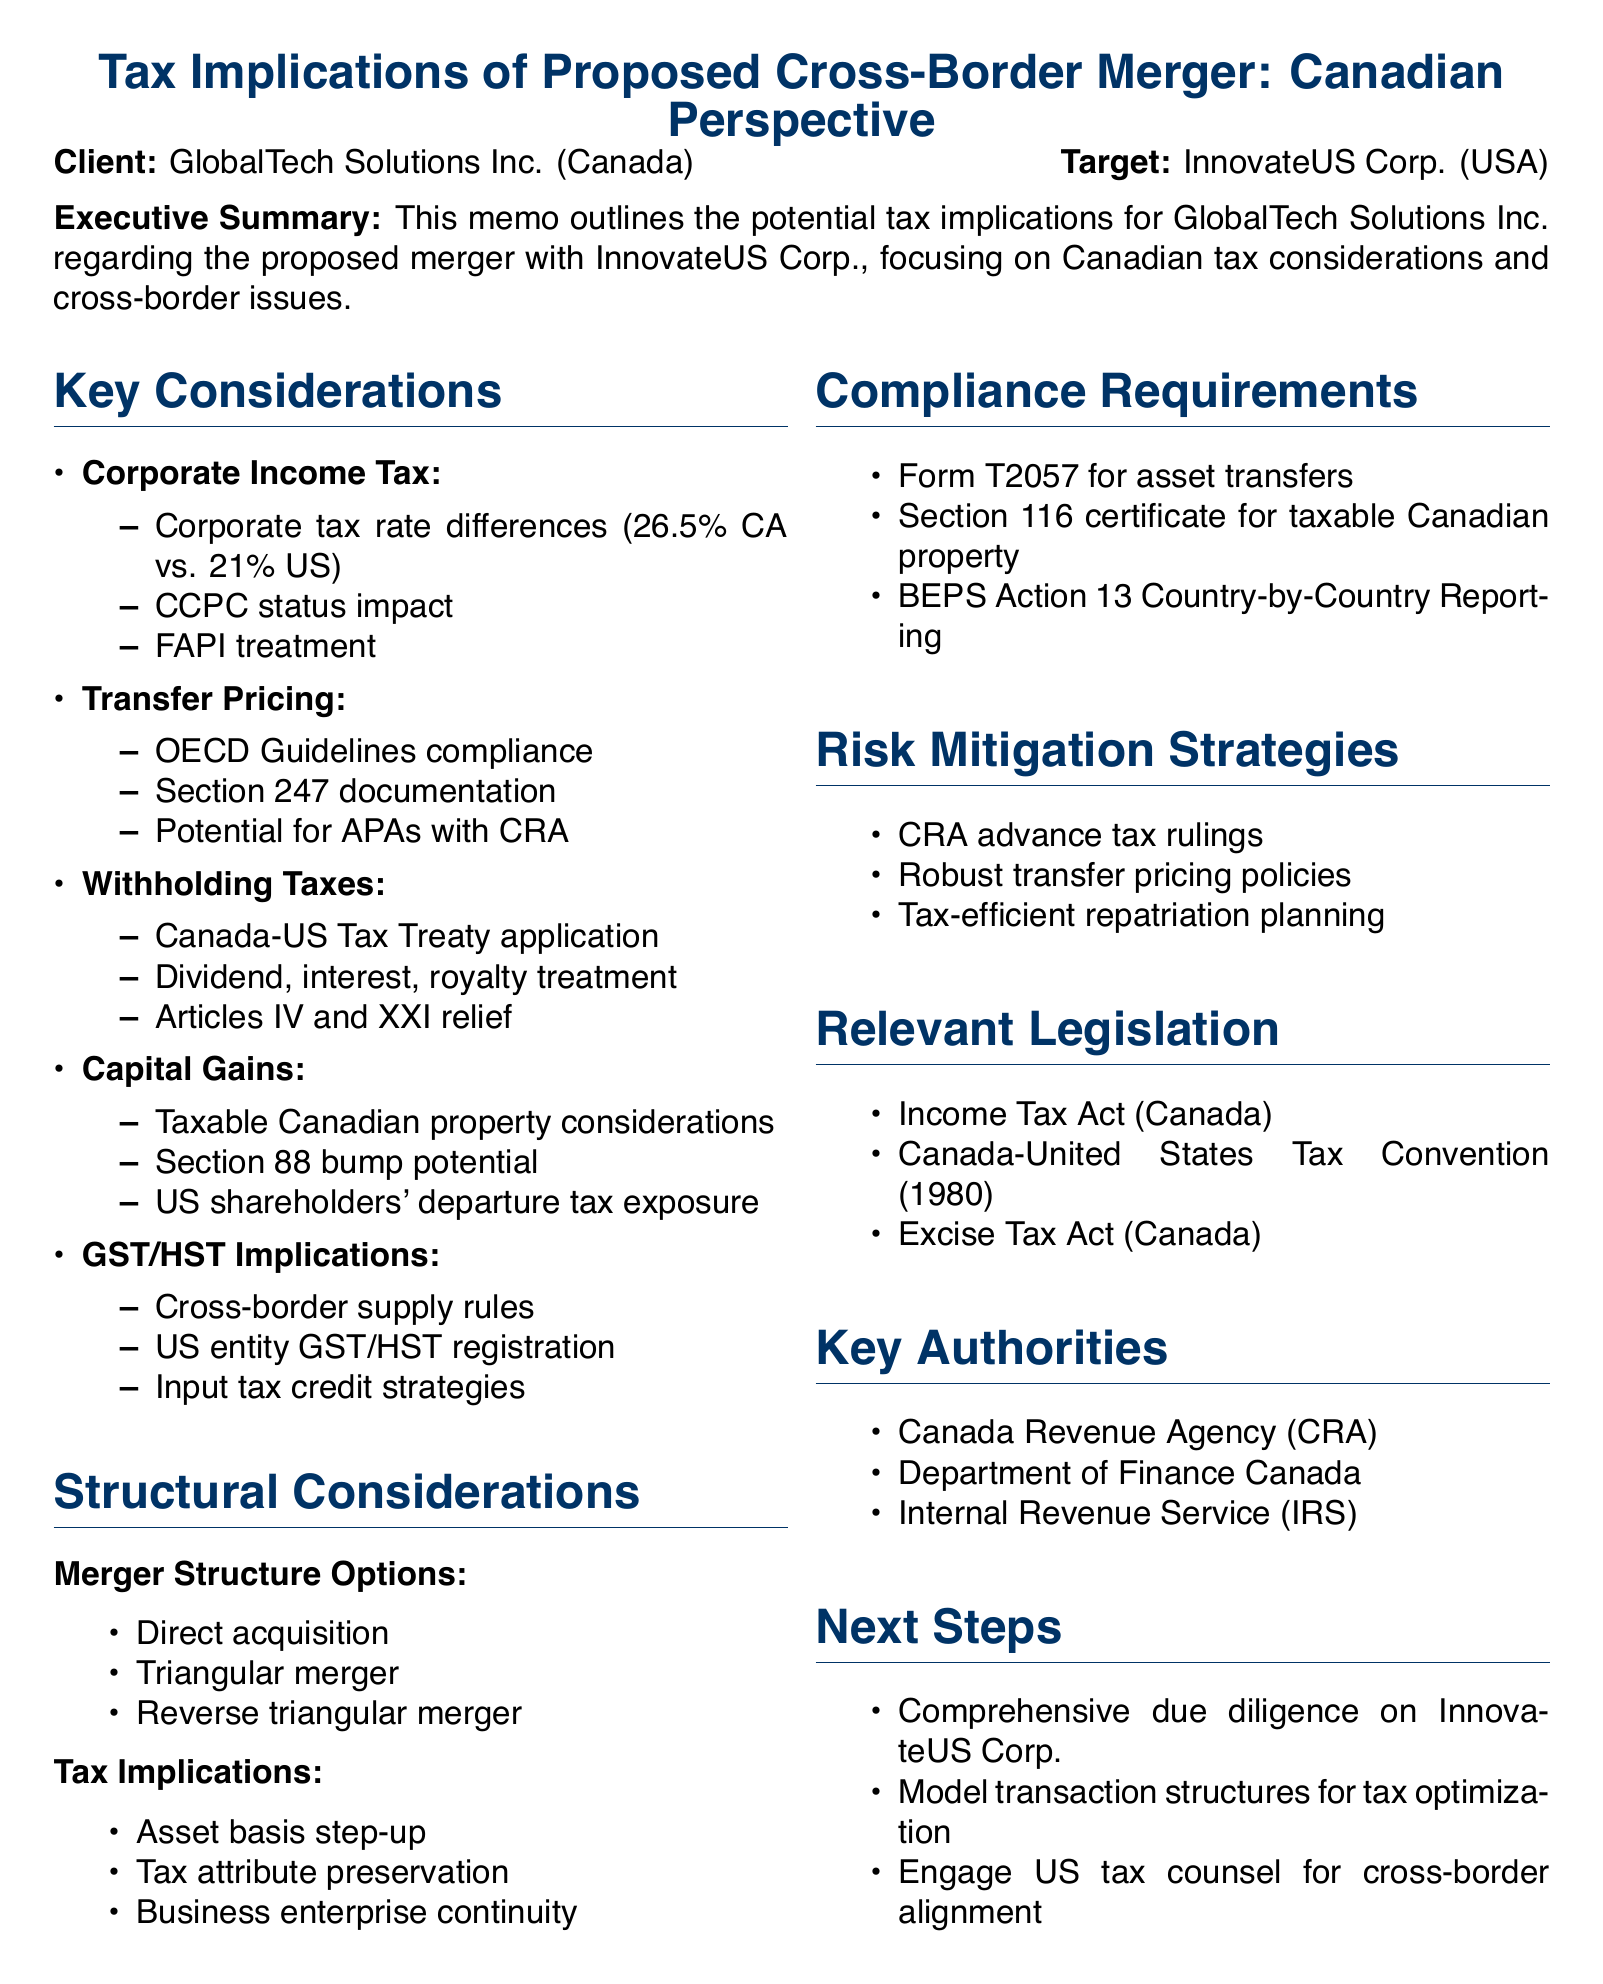what is the client name? The client name is explicitly mentioned in the document as GlobalTech Solutions Inc.
Answer: GlobalTech Solutions Inc what is the target company? The document identifies the target company involved in the merger as InnovateUS Corp.
Answer: InnovateUS Corp what is the corporate tax rate in Canada? The document states that the corporate tax rate in Canada is 26.5%.
Answer: 26.5% what is the potential application mentioned in Capital Gains? The document references the potential application of Section 88 bump on acquisition of Canadian target under Capital Gains considerations.
Answer: Section 88 bump which form is required for asset transfers? The document lists Form T2057 as necessary for asset transfers under compliance requirements.
Answer: Form T2057 what is one of the risk mitigation strategies suggested? The document advises obtaining advance tax rulings from CRA as a risk mitigation strategy.
Answer: Advance tax rulings from CRA what are the three merger structure options listed? The document outlines three options: direct acquisition, triangular merger, and reverse triangular merger.
Answer: Direct acquisition, triangular merger, reverse triangular merger which agency is responsible for advance pricing agreements? The document indicates that the Canada Revenue Agency (CRA) handles advance pricing agreements.
Answer: Canada Revenue Agency (CRA) what is the main focus of the executive summary? The executive summary outlines the potential tax implications for GlobalTech Solutions Inc. regarding the proposed merger with InnovateUS Corp.
Answer: Potential tax implications for GlobalTech Solutions Inc 